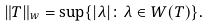Convert formula to latex. <formula><loc_0><loc_0><loc_500><loc_500>\| T \| _ { w } = \sup \{ | \lambda | \colon \lambda \in W ( T ) \} .</formula> 